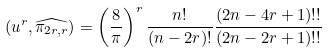<formula> <loc_0><loc_0><loc_500><loc_500>( u ^ { r } , \widehat { \pi _ { 2 r , r } } ) = \left ( \frac { 8 } { \pi } \right ) ^ { r } \frac { n ! } { ( n - 2 r ) ! } \frac { ( 2 n - 4 r + 1 ) ! ! } { ( 2 n - 2 r + 1 ) ! ! }</formula> 